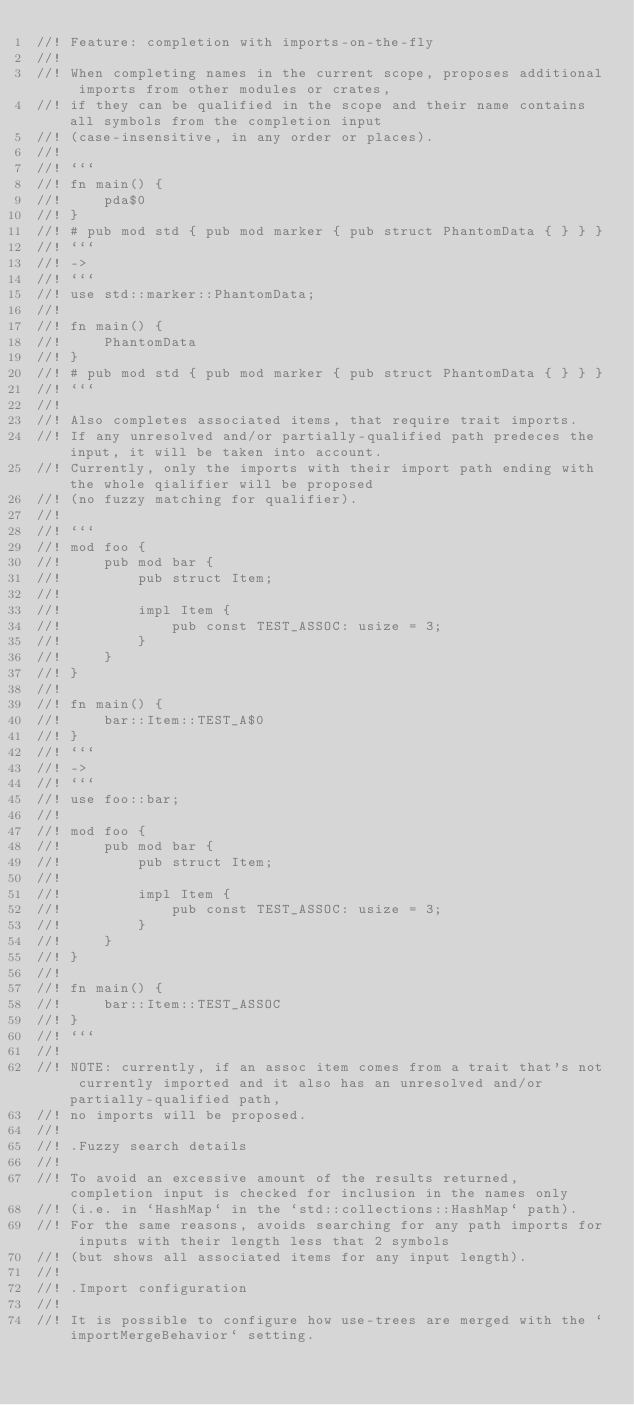<code> <loc_0><loc_0><loc_500><loc_500><_Rust_>//! Feature: completion with imports-on-the-fly
//!
//! When completing names in the current scope, proposes additional imports from other modules or crates,
//! if they can be qualified in the scope and their name contains all symbols from the completion input
//! (case-insensitive, in any order or places).
//!
//! ```
//! fn main() {
//!     pda$0
//! }
//! # pub mod std { pub mod marker { pub struct PhantomData { } } }
//! ```
//! ->
//! ```
//! use std::marker::PhantomData;
//!
//! fn main() {
//!     PhantomData
//! }
//! # pub mod std { pub mod marker { pub struct PhantomData { } } }
//! ```
//!
//! Also completes associated items, that require trait imports.
//! If any unresolved and/or partially-qualified path predeces the input, it will be taken into account.
//! Currently, only the imports with their import path ending with the whole qialifier will be proposed
//! (no fuzzy matching for qualifier).
//!
//! ```
//! mod foo {
//!     pub mod bar {
//!         pub struct Item;
//!
//!         impl Item {
//!             pub const TEST_ASSOC: usize = 3;
//!         }
//!     }
//! }
//!
//! fn main() {
//!     bar::Item::TEST_A$0
//! }
//! ```
//! ->
//! ```
//! use foo::bar;
//!
//! mod foo {
//!     pub mod bar {
//!         pub struct Item;
//!
//!         impl Item {
//!             pub const TEST_ASSOC: usize = 3;
//!         }
//!     }
//! }
//!
//! fn main() {
//!     bar::Item::TEST_ASSOC
//! }
//! ```
//!
//! NOTE: currently, if an assoc item comes from a trait that's not currently imported and it also has an unresolved and/or partially-qualified path,
//! no imports will be proposed.
//!
//! .Fuzzy search details
//!
//! To avoid an excessive amount of the results returned, completion input is checked for inclusion in the names only
//! (i.e. in `HashMap` in the `std::collections::HashMap` path).
//! For the same reasons, avoids searching for any path imports for inputs with their length less that 2 symbols
//! (but shows all associated items for any input length).
//!
//! .Import configuration
//!
//! It is possible to configure how use-trees are merged with the `importMergeBehavior` setting.</code> 